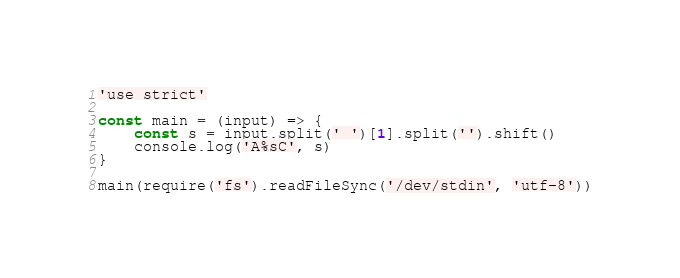<code> <loc_0><loc_0><loc_500><loc_500><_JavaScript_>'use strict'

const main = (input) => {
    const s = input.split(' ')[1].split('').shift()
    console.log('A%sC', s)
}

main(require('fs').readFileSync('/dev/stdin', 'utf-8'))</code> 